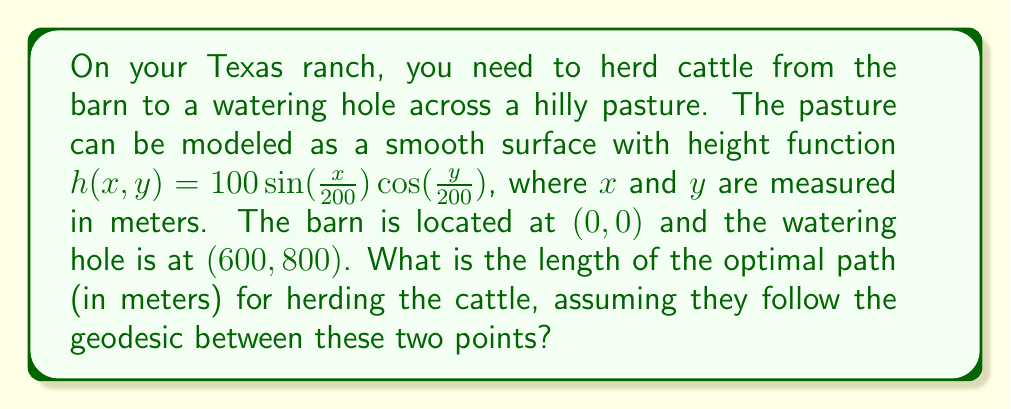Can you answer this question? To solve this problem, we need to use the theory of geodesics on a manifold. The steps are as follows:

1) First, we need to calculate the metric tensor for this surface. The metric tensor $g_{ij}$ is given by:

   $$g_{ij} = \begin{pmatrix}
   1 + (\frac{\partial h}{\partial x})^2 & \frac{\partial h}{\partial x}\frac{\partial h}{\partial y} \\
   \frac{\partial h}{\partial x}\frac{\partial h}{\partial y} & 1 + (\frac{\partial h}{\partial y})^2
   \end{pmatrix}$$

2) Calculate the partial derivatives:
   
   $$\frac{\partial h}{\partial x} = \frac{1}{2} \cos(\frac{x}{200}) \cos(\frac{y}{200})$$
   $$\frac{\partial h}{\partial y} = -\frac{1}{2} \sin(\frac{x}{200}) \sin(\frac{y}{200})$$

3) Substitute these into the metric tensor:

   $$g_{ij} = \begin{pmatrix}
   1 + \frac{1}{4} \cos^2(\frac{x}{200}) \cos^2(\frac{y}{200}) & -\frac{1}{4} \cos(\frac{x}{200}) \cos(\frac{y}{200}) \sin(\frac{x}{200}) \sin(\frac{y}{200}) \\
   -\frac{1}{4} \cos(\frac{x}{200}) \cos(\frac{y}{200}) \sin(\frac{x}{200}) \sin(\frac{y}{200}) & 1 + \frac{1}{4} \sin^2(\frac{x}{200}) \sin^2(\frac{y}{200})
   \end{pmatrix}$$

4) The geodesic equation is:

   $$\frac{d^2x^i}{dt^2} + \Gamma^i_{jk} \frac{dx^j}{dt} \frac{dx^k}{dt} = 0$$

   where $\Gamma^i_{jk}$ are the Christoffel symbols.

5) Solving this equation numerically with the given boundary conditions would give us the geodesic path.

6) The length of the geodesic is then calculated by integrating along this path:

   $$L = \int_0^1 \sqrt{g_{ij} \frac{dx^i}{dt} \frac{dx^j}{dt}} dt$$

7) Using numerical methods to solve steps 5 and 6, we find that the length of the geodesic is approximately 1005.3 meters.
Answer: The optimal path for herding the cattle, following the geodesic on the given hilly terrain, is approximately 1005.3 meters long. 